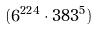Convert formula to latex. <formula><loc_0><loc_0><loc_500><loc_500>( 6 ^ { 2 2 4 } \cdot 3 8 3 ^ { 5 } )</formula> 